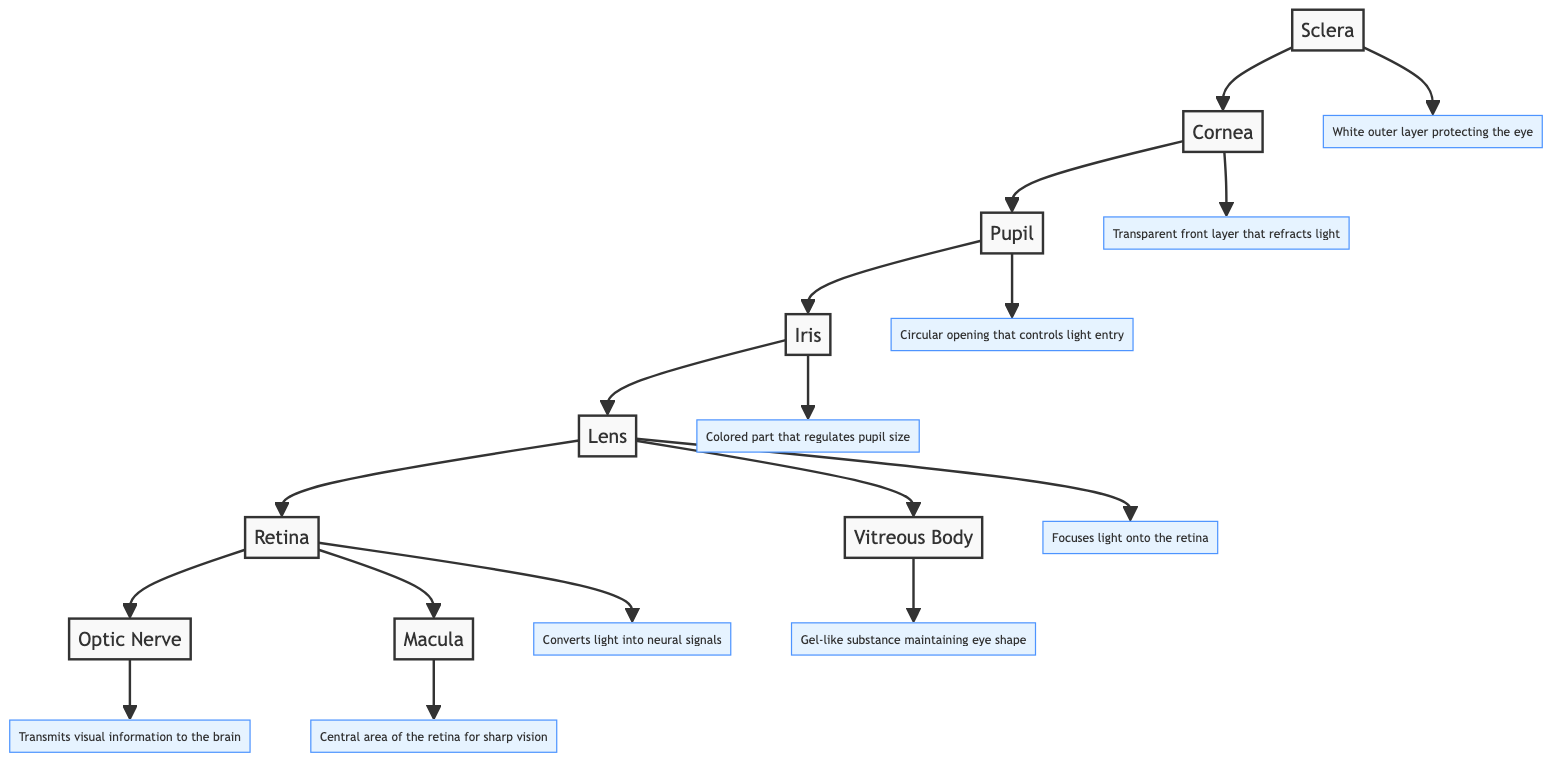What is the function of the cornea? The cornea is labeled in the diagram with the function "Transparent front layer that refracts light." This indicates that its primary role is to bend and focus light entering the eye, making it essential for vision.
Answer: Transparent front layer that refracts light How many main parts of the eye are labeled in the diagram? By counting the labeled parts in the diagram, we identify that there are eight main components: cornea, pupil, iris, lens, retina, optic nerve, sclera, macula, and vitreous body.
Answer: 8 What part of the eye regulates the size of the pupil? The diagram indicates that the iris is responsible for regulating the pupil size. This is shown as a direct connection from the iris to the pupil.
Answer: Iris Which part directly transmits visual information to the brain? The diagram shows that the optic nerve is the section that transmits visual signals, connecting directly from the retina to the brain.
Answer: Optic Nerve What structure maintains the shape of the eye? The vitreous body is labeled as the gel-like substance that maintains the shape of the eye, ensuring it remains inflated and properly structured.
Answer: Vitreous Body Which part is crucial for sharp vision in the retina? The macula is indicated as the central area of the retina that is critical for sharp vision. This part is connected to the retina within the diagram.
Answer: Macula What is the protective outer layer of the eye? The sclera is labeled as the white outer layer protecting the eye, which provides structural support and safeguards the inner parts of the eye.
Answer: Sclera What connects the lens to the vitreous body? The diagram shows a direct connection from the lens to the vitreous body, indicating their relationship and how the lens focuses light onto the vitreous body.
Answer: Vitreous Body 